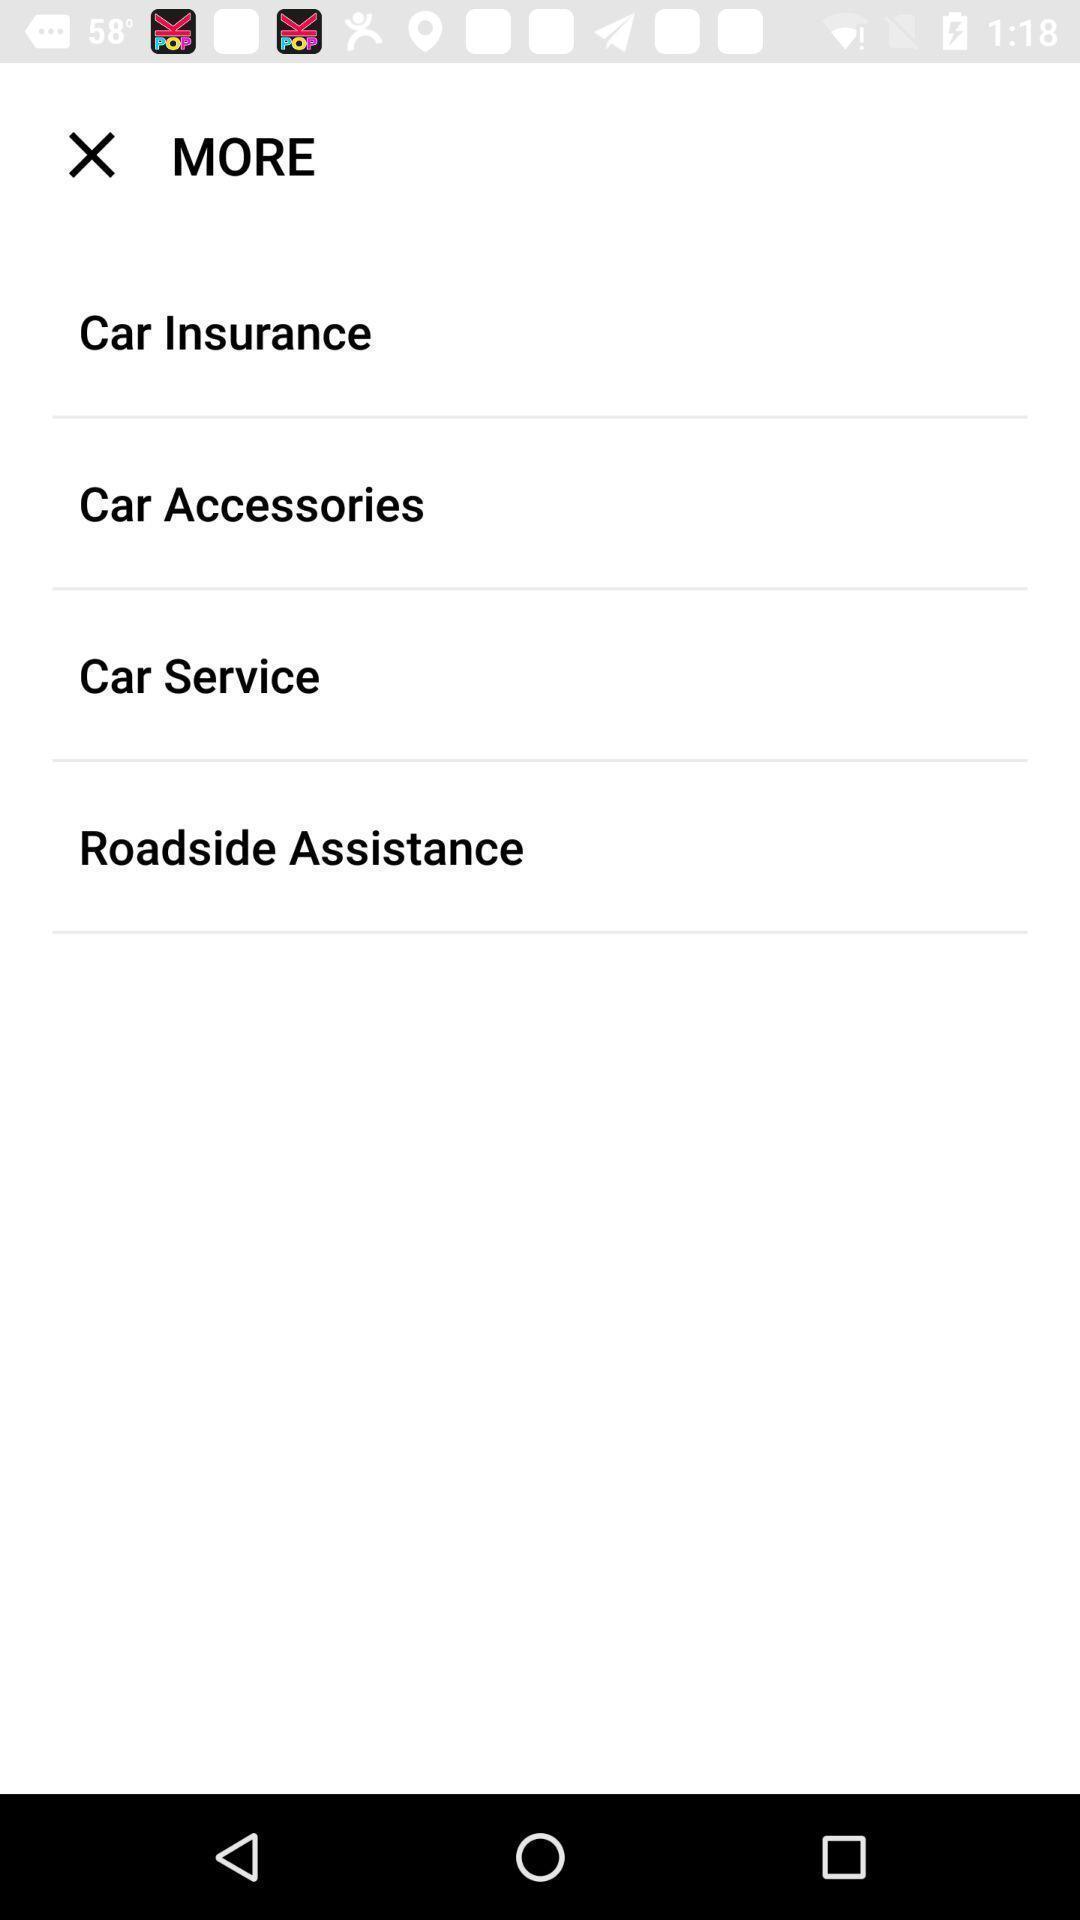Explain what's happening in this screen capture. Page displaying the various options. 